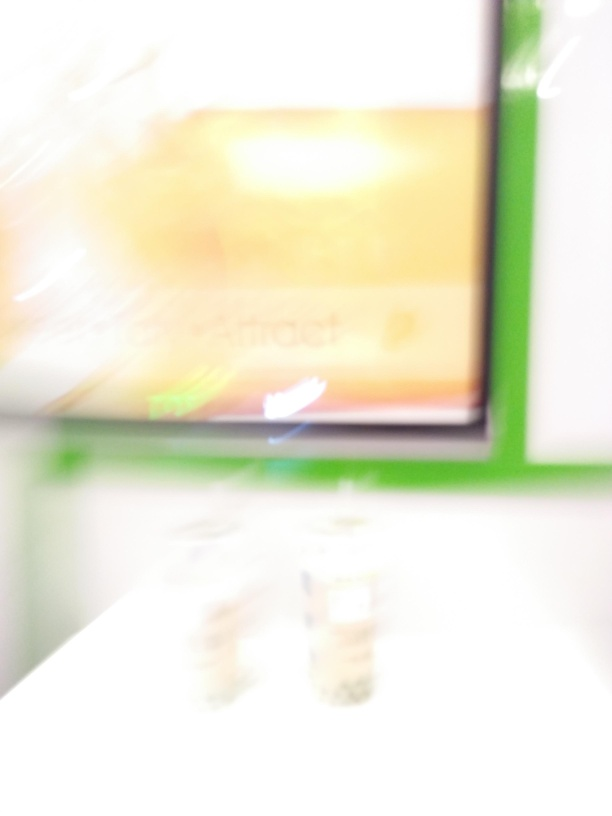Could you guess the time of day this photo was taken? Given only the blurred lights and what might be indoor illumination, it's virtually impossible to determine the time of day from this image. Are there any identifiable objects or features in this image? The blur obscures most of the image, but it seems there may be some text and rectangular shapes that could be signs or displays. Unfortunately, the specifics are indiscernible without a clearer image. 